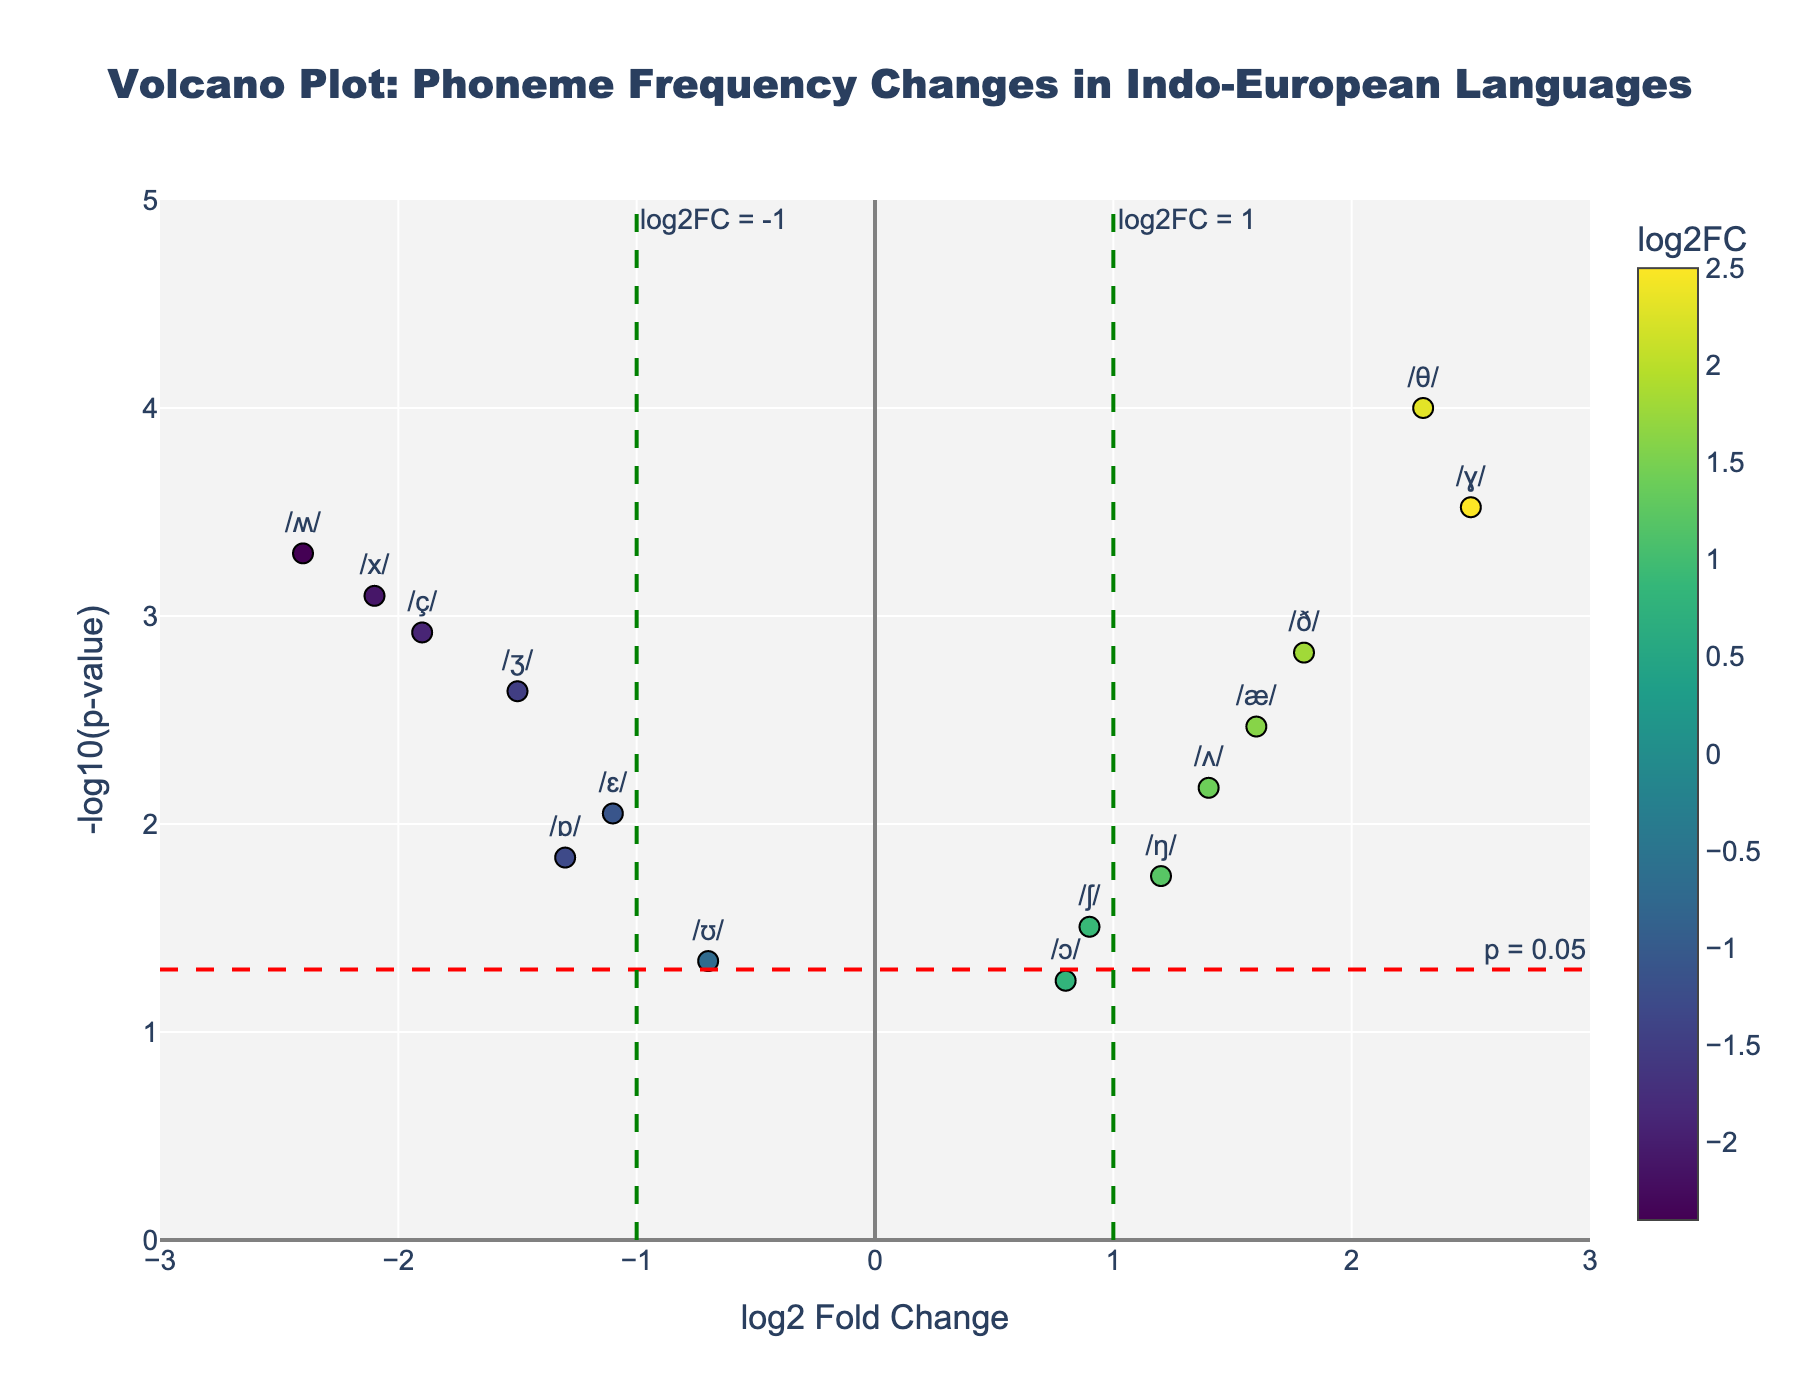What is the title of the plot? The title is located at the top of the plot, which is typically the most prominent text and provides a summary of the figure's content.
Answer: Volcano Plot: Phoneme Frequency Changes in Indo-European Languages What do the x-axis and y-axis represent? The x-axis shows "log2 Fold Change," and the y-axis shows "-log10(p-value)," indicated by the labels near the axes.
Answer: log2 Fold Change, -log10(p-value) How many phonemes have a log2 Fold Change greater than 1? By examining the x-axis, identify data points to the right of the green line at log2FC=1. There are four such points: /θ/, /ð/, /ɣ/, and /æ/.
Answer: 4 What is the significance threshold line on the y-axis? The y-axis has a horizontal red dashed line, which is labeled as "p = 0.05."
Answer: p = 0.05 Which phoneme shows the highest log2 Fold Change? The highest log2 Fold Change corresponds to the point farthest to the right on the x-axis, identified as the phoneme /ɣ/.
Answer: /ɣ/ Which phoneme has the lowest -log10(p-value)? The lowest -log10(p-value) would be associated with the point closest to the x-axis, identified as the phoneme /ɔ/.
Answer: /ɔ/ Did any phonemes decrease significantly in frequency? Points far to the left with high y-values indicate significant decreases. Phonemes /ʒ/, /x/, /ɛ/, /ɒ/, /ç/, and /ʍ/ meet this criterion.
Answer: Yes What is the log2 Fold Change and p-value for the phoneme /θ/? The plot hover text or the specific location can identify the values. /θ/ has a log2FC of 2.3 and a p-value of 0.0001.
Answer: 2.3, 0.0001 Which phoneme has a log2 Fold Change of approximately 1.4 and what is its p-value? Locate the point near the x=1.4 line and check its values. The phoneme /ʌ/ has a log2FC of 1.4 and a p-value of 0.0067.
Answer: /ʌ/, 0.0067 What is the median log2 Fold Change value for the phonemes with -log10(p-value) > 1? Identify the points with -log10(p-value) greater than 1, extract their log2FC values, and calculate the median. The relevant phonemes are /θ/, /ð/, /ʒ/, /x/, /æ/, /ɒ/, /ç/, and /ʍ/ with log2FC values 2.3, 1.8, -1.5, -2.1, 1.6, -1.3, -1.9, -2.4. Median = (1.6 + -1.3) / 2 = 0.15.
Answer: 0.15 